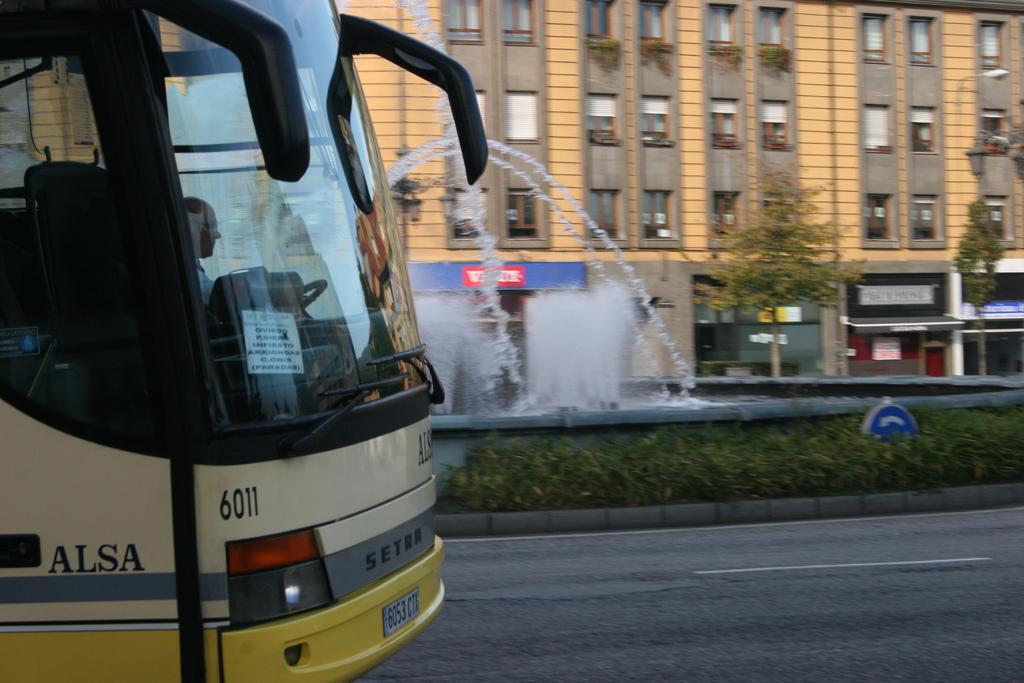In one or two sentences, can you explain what this image depicts? On the left side of the image there is a person sitting on the bus. In front of the image there is a road. In the center of the image there is a fountain. There are plants. In the background of the image there are trees, buildings. 